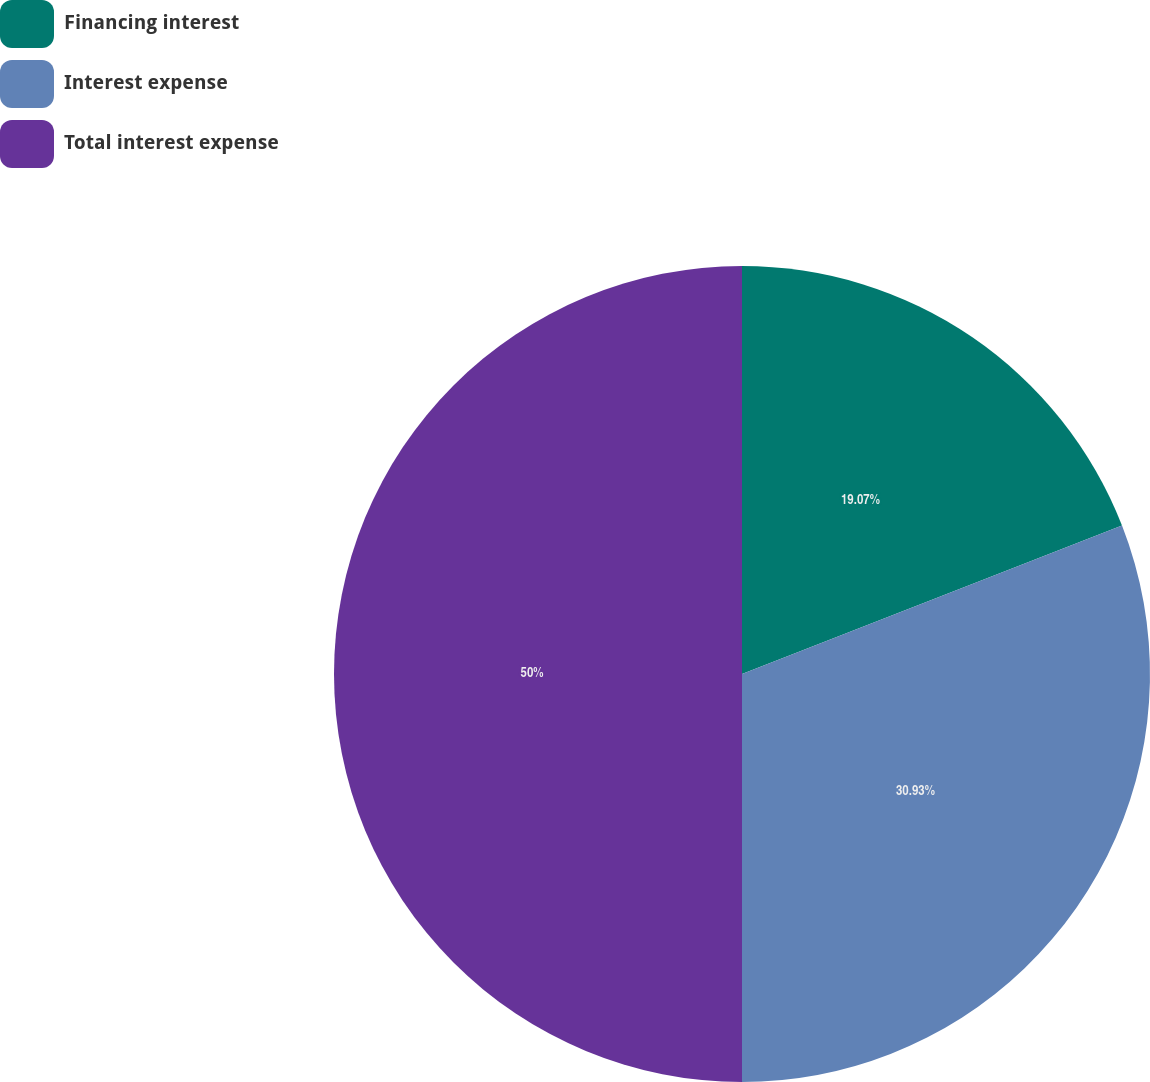Convert chart to OTSL. <chart><loc_0><loc_0><loc_500><loc_500><pie_chart><fcel>Financing interest<fcel>Interest expense<fcel>Total interest expense<nl><fcel>19.07%<fcel>30.93%<fcel>50.0%<nl></chart> 